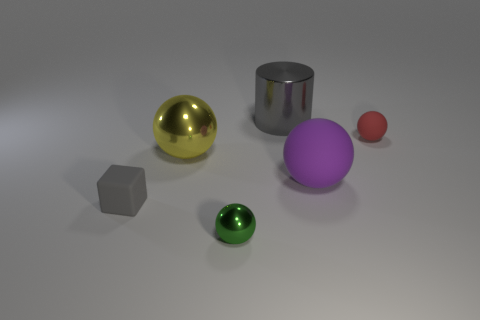What number of other objects are the same material as the big yellow thing?
Offer a terse response. 2. How many things are metal balls that are in front of the large yellow shiny thing or tiny objects that are right of the gray shiny cylinder?
Offer a very short reply. 2. There is a big yellow object that is the same shape as the green metallic object; what material is it?
Your answer should be compact. Metal. Is there a big green metallic cube?
Provide a short and direct response. No. There is a object that is both in front of the purple matte thing and on the right side of the gray rubber object; how big is it?
Keep it short and to the point. Small. The red matte object is what shape?
Give a very brief answer. Sphere. There is a big sphere that is right of the gray cylinder; are there any metallic balls that are in front of it?
Provide a succinct answer. Yes. What material is the green sphere that is the same size as the red ball?
Your response must be concise. Metal. Are there any red matte objects that have the same size as the green metallic ball?
Your answer should be compact. Yes. There is a small thing behind the gray matte thing; what material is it?
Your answer should be compact. Rubber. 